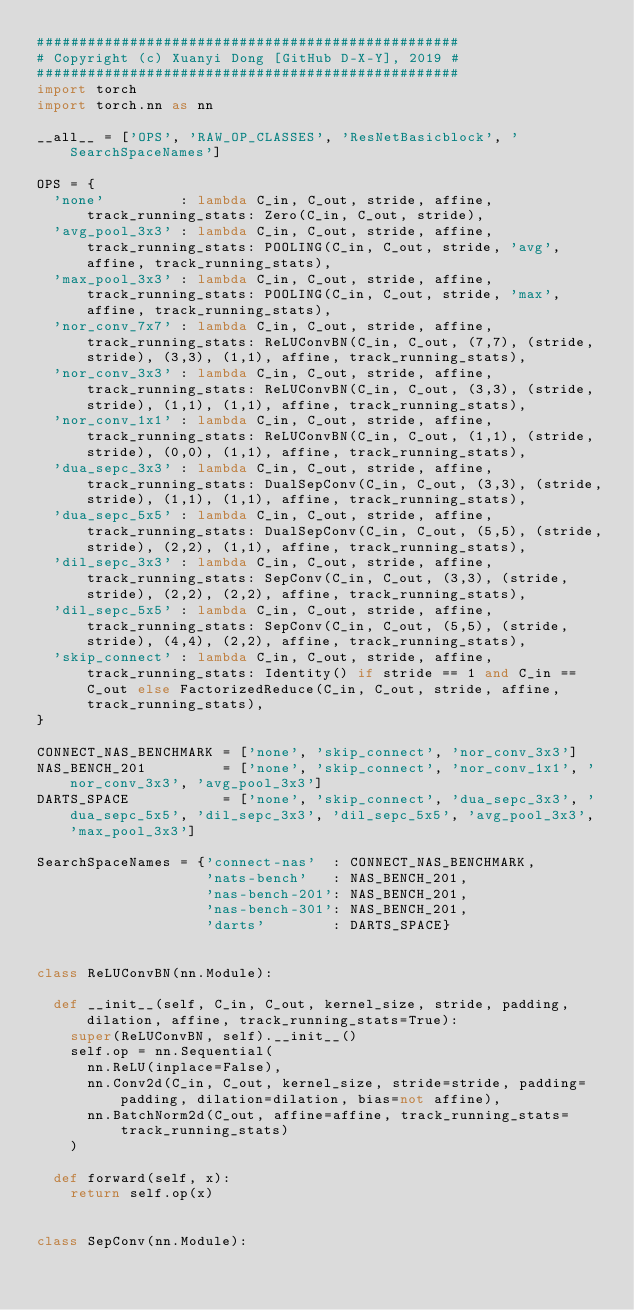Convert code to text. <code><loc_0><loc_0><loc_500><loc_500><_Python_>##################################################
# Copyright (c) Xuanyi Dong [GitHub D-X-Y], 2019 #
##################################################
import torch
import torch.nn as nn

__all__ = ['OPS', 'RAW_OP_CLASSES', 'ResNetBasicblock', 'SearchSpaceNames']

OPS = {
  'none'         : lambda C_in, C_out, stride, affine, track_running_stats: Zero(C_in, C_out, stride),
  'avg_pool_3x3' : lambda C_in, C_out, stride, affine, track_running_stats: POOLING(C_in, C_out, stride, 'avg', affine, track_running_stats),
  'max_pool_3x3' : lambda C_in, C_out, stride, affine, track_running_stats: POOLING(C_in, C_out, stride, 'max', affine, track_running_stats),
  'nor_conv_7x7' : lambda C_in, C_out, stride, affine, track_running_stats: ReLUConvBN(C_in, C_out, (7,7), (stride,stride), (3,3), (1,1), affine, track_running_stats),
  'nor_conv_3x3' : lambda C_in, C_out, stride, affine, track_running_stats: ReLUConvBN(C_in, C_out, (3,3), (stride,stride), (1,1), (1,1), affine, track_running_stats),
  'nor_conv_1x1' : lambda C_in, C_out, stride, affine, track_running_stats: ReLUConvBN(C_in, C_out, (1,1), (stride,stride), (0,0), (1,1), affine, track_running_stats),
  'dua_sepc_3x3' : lambda C_in, C_out, stride, affine, track_running_stats: DualSepConv(C_in, C_out, (3,3), (stride,stride), (1,1), (1,1), affine, track_running_stats),
  'dua_sepc_5x5' : lambda C_in, C_out, stride, affine, track_running_stats: DualSepConv(C_in, C_out, (5,5), (stride,stride), (2,2), (1,1), affine, track_running_stats),
  'dil_sepc_3x3' : lambda C_in, C_out, stride, affine, track_running_stats: SepConv(C_in, C_out, (3,3), (stride,stride), (2,2), (2,2), affine, track_running_stats),
  'dil_sepc_5x5' : lambda C_in, C_out, stride, affine, track_running_stats: SepConv(C_in, C_out, (5,5), (stride,stride), (4,4), (2,2), affine, track_running_stats),
  'skip_connect' : lambda C_in, C_out, stride, affine, track_running_stats: Identity() if stride == 1 and C_in == C_out else FactorizedReduce(C_in, C_out, stride, affine, track_running_stats),
}

CONNECT_NAS_BENCHMARK = ['none', 'skip_connect', 'nor_conv_3x3']
NAS_BENCH_201         = ['none', 'skip_connect', 'nor_conv_1x1', 'nor_conv_3x3', 'avg_pool_3x3']
DARTS_SPACE           = ['none', 'skip_connect', 'dua_sepc_3x3', 'dua_sepc_5x5', 'dil_sepc_3x3', 'dil_sepc_5x5', 'avg_pool_3x3', 'max_pool_3x3']

SearchSpaceNames = {'connect-nas'  : CONNECT_NAS_BENCHMARK,
                    'nats-bench'   : NAS_BENCH_201,
                    'nas-bench-201': NAS_BENCH_201,
                    'nas-bench-301': NAS_BENCH_201,
                    'darts'        : DARTS_SPACE}


class ReLUConvBN(nn.Module):

  def __init__(self, C_in, C_out, kernel_size, stride, padding, dilation, affine, track_running_stats=True):
    super(ReLUConvBN, self).__init__()
    self.op = nn.Sequential(
      nn.ReLU(inplace=False),
      nn.Conv2d(C_in, C_out, kernel_size, stride=stride, padding=padding, dilation=dilation, bias=not affine),
      nn.BatchNorm2d(C_out, affine=affine, track_running_stats=track_running_stats)
    )

  def forward(self, x):
    return self.op(x)


class SepConv(nn.Module):
    </code> 